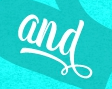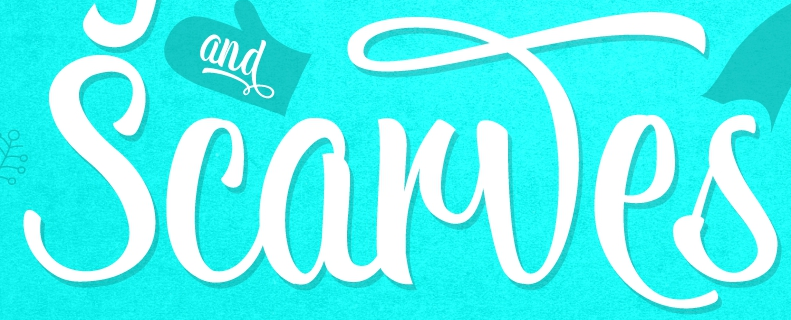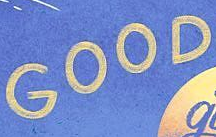Transcribe the words shown in these images in order, separated by a semicolon. and; Scarwes; GOOD 